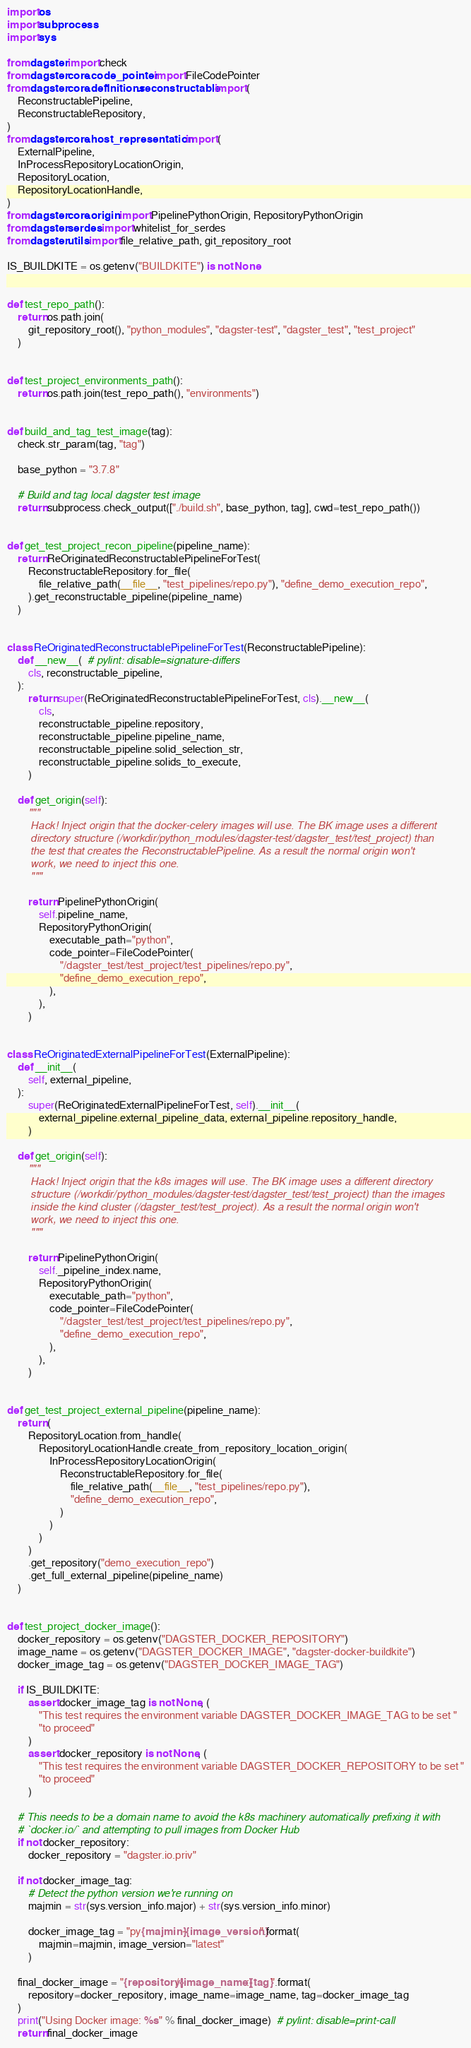Convert code to text. <code><loc_0><loc_0><loc_500><loc_500><_Python_>import os
import subprocess
import sys

from dagster import check
from dagster.core.code_pointer import FileCodePointer
from dagster.core.definitions.reconstructable import (
    ReconstructablePipeline,
    ReconstructableRepository,
)
from dagster.core.host_representation import (
    ExternalPipeline,
    InProcessRepositoryLocationOrigin,
    RepositoryLocation,
    RepositoryLocationHandle,
)
from dagster.core.origin import PipelinePythonOrigin, RepositoryPythonOrigin
from dagster.serdes import whitelist_for_serdes
from dagster.utils import file_relative_path, git_repository_root

IS_BUILDKITE = os.getenv("BUILDKITE") is not None


def test_repo_path():
    return os.path.join(
        git_repository_root(), "python_modules", "dagster-test", "dagster_test", "test_project"
    )


def test_project_environments_path():
    return os.path.join(test_repo_path(), "environments")


def build_and_tag_test_image(tag):
    check.str_param(tag, "tag")

    base_python = "3.7.8"

    # Build and tag local dagster test image
    return subprocess.check_output(["./build.sh", base_python, tag], cwd=test_repo_path())


def get_test_project_recon_pipeline(pipeline_name):
    return ReOriginatedReconstructablePipelineForTest(
        ReconstructableRepository.for_file(
            file_relative_path(__file__, "test_pipelines/repo.py"), "define_demo_execution_repo",
        ).get_reconstructable_pipeline(pipeline_name)
    )


class ReOriginatedReconstructablePipelineForTest(ReconstructablePipeline):
    def __new__(  # pylint: disable=signature-differs
        cls, reconstructable_pipeline,
    ):
        return super(ReOriginatedReconstructablePipelineForTest, cls).__new__(
            cls,
            reconstructable_pipeline.repository,
            reconstructable_pipeline.pipeline_name,
            reconstructable_pipeline.solid_selection_str,
            reconstructable_pipeline.solids_to_execute,
        )

    def get_origin(self):
        """
        Hack! Inject origin that the docker-celery images will use. The BK image uses a different
        directory structure (/workdir/python_modules/dagster-test/dagster_test/test_project) than
        the test that creates the ReconstructablePipeline. As a result the normal origin won't
        work, we need to inject this one.
        """

        return PipelinePythonOrigin(
            self.pipeline_name,
            RepositoryPythonOrigin(
                executable_path="python",
                code_pointer=FileCodePointer(
                    "/dagster_test/test_project/test_pipelines/repo.py",
                    "define_demo_execution_repo",
                ),
            ),
        )


class ReOriginatedExternalPipelineForTest(ExternalPipeline):
    def __init__(
        self, external_pipeline,
    ):
        super(ReOriginatedExternalPipelineForTest, self).__init__(
            external_pipeline.external_pipeline_data, external_pipeline.repository_handle,
        )

    def get_origin(self):
        """
        Hack! Inject origin that the k8s images will use. The BK image uses a different directory
        structure (/workdir/python_modules/dagster-test/dagster_test/test_project) than the images
        inside the kind cluster (/dagster_test/test_project). As a result the normal origin won't
        work, we need to inject this one.
        """

        return PipelinePythonOrigin(
            self._pipeline_index.name,
            RepositoryPythonOrigin(
                executable_path="python",
                code_pointer=FileCodePointer(
                    "/dagster_test/test_project/test_pipelines/repo.py",
                    "define_demo_execution_repo",
                ),
            ),
        )


def get_test_project_external_pipeline(pipeline_name):
    return (
        RepositoryLocation.from_handle(
            RepositoryLocationHandle.create_from_repository_location_origin(
                InProcessRepositoryLocationOrigin(
                    ReconstructableRepository.for_file(
                        file_relative_path(__file__, "test_pipelines/repo.py"),
                        "define_demo_execution_repo",
                    )
                )
            )
        )
        .get_repository("demo_execution_repo")
        .get_full_external_pipeline(pipeline_name)
    )


def test_project_docker_image():
    docker_repository = os.getenv("DAGSTER_DOCKER_REPOSITORY")
    image_name = os.getenv("DAGSTER_DOCKER_IMAGE", "dagster-docker-buildkite")
    docker_image_tag = os.getenv("DAGSTER_DOCKER_IMAGE_TAG")

    if IS_BUILDKITE:
        assert docker_image_tag is not None, (
            "This test requires the environment variable DAGSTER_DOCKER_IMAGE_TAG to be set "
            "to proceed"
        )
        assert docker_repository is not None, (
            "This test requires the environment variable DAGSTER_DOCKER_REPOSITORY to be set "
            "to proceed"
        )

    # This needs to be a domain name to avoid the k8s machinery automatically prefixing it with
    # `docker.io/` and attempting to pull images from Docker Hub
    if not docker_repository:
        docker_repository = "dagster.io.priv"

    if not docker_image_tag:
        # Detect the python version we're running on
        majmin = str(sys.version_info.major) + str(sys.version_info.minor)

        docker_image_tag = "py{majmin}-{image_version}".format(
            majmin=majmin, image_version="latest"
        )

    final_docker_image = "{repository}/{image_name}:{tag}".format(
        repository=docker_repository, image_name=image_name, tag=docker_image_tag
    )
    print("Using Docker image: %s" % final_docker_image)  # pylint: disable=print-call
    return final_docker_image
</code> 